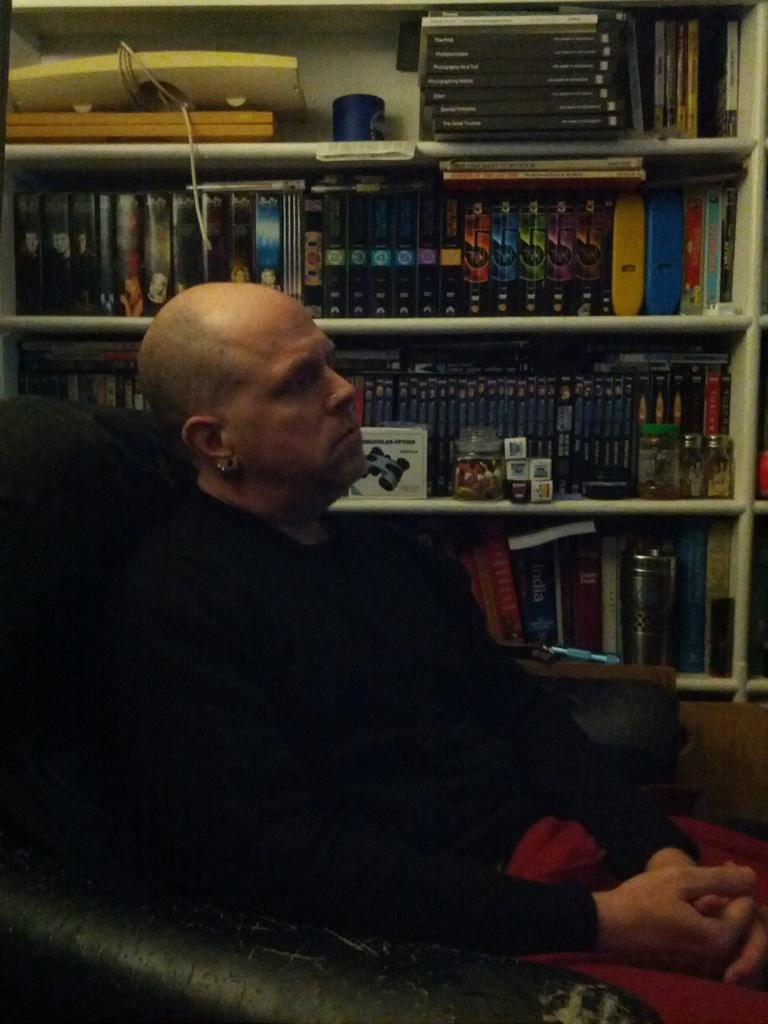What is the man in the image doing? The man is sitting on a sofa in the image. What is the man wearing? The man is wearing clothes. What can be seen on the shelves in the image? There are books on shelves in the image. What type of containers are visible in the image? There are glass jars visible in the image. What type of soup is being prepared in the glass container in the image? There is no soup or glass container present in the image. 